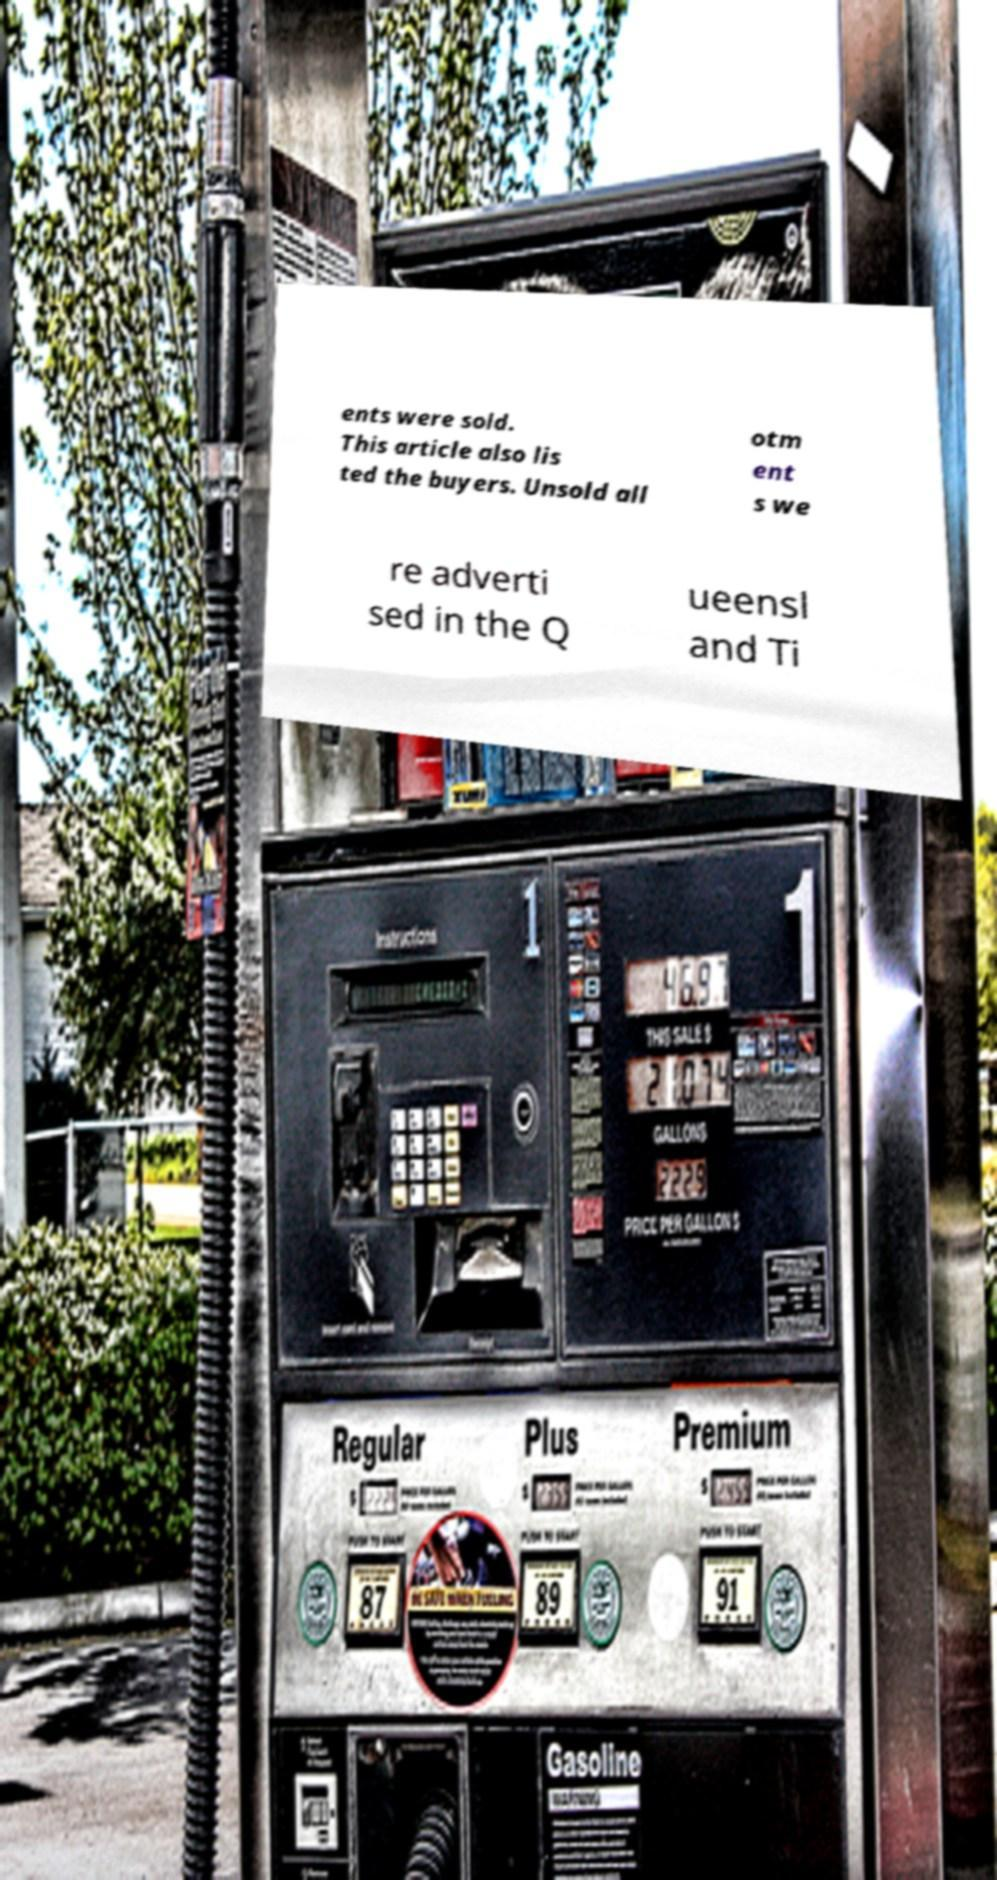Please identify and transcribe the text found in this image. ents were sold. This article also lis ted the buyers. Unsold all otm ent s we re adverti sed in the Q ueensl and Ti 